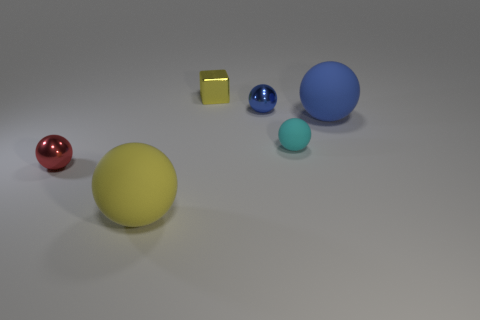What number of other objects are there of the same size as the blue rubber object?
Ensure brevity in your answer.  1. What color is the small rubber thing?
Offer a very short reply. Cyan. What number of metal objects are yellow blocks or tiny objects?
Give a very brief answer. 3. There is a blue thing that is behind the big matte sphere behind the small ball to the left of the tiny blue shiny thing; what is its size?
Give a very brief answer. Small. What size is the ball that is in front of the tiny cyan object and to the right of the red metal sphere?
Keep it short and to the point. Large. There is a small metal ball right of the red shiny ball; is its color the same as the rubber object on the left side of the tiny shiny cube?
Keep it short and to the point. No. There is a tiny yellow metal block; what number of large rubber balls are on the right side of it?
Ensure brevity in your answer.  1. There is a big sphere that is right of the metallic sphere that is on the right side of the tiny shiny block; are there any blue matte balls to the left of it?
Provide a short and direct response. No. How many yellow things are the same size as the blue shiny thing?
Your answer should be compact. 1. What material is the big object behind the tiny red sphere that is in front of the blue matte ball made of?
Provide a short and direct response. Rubber. 